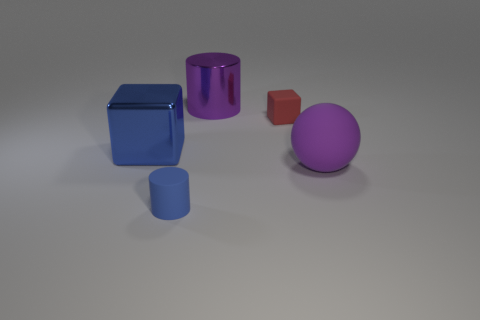Add 5 blue metallic things. How many objects exist? 10 Subtract all cylinders. How many objects are left? 3 Subtract all green matte cylinders. Subtract all small rubber blocks. How many objects are left? 4 Add 3 small blue rubber objects. How many small blue rubber objects are left? 4 Add 5 purple spheres. How many purple spheres exist? 6 Subtract 1 purple cylinders. How many objects are left? 4 